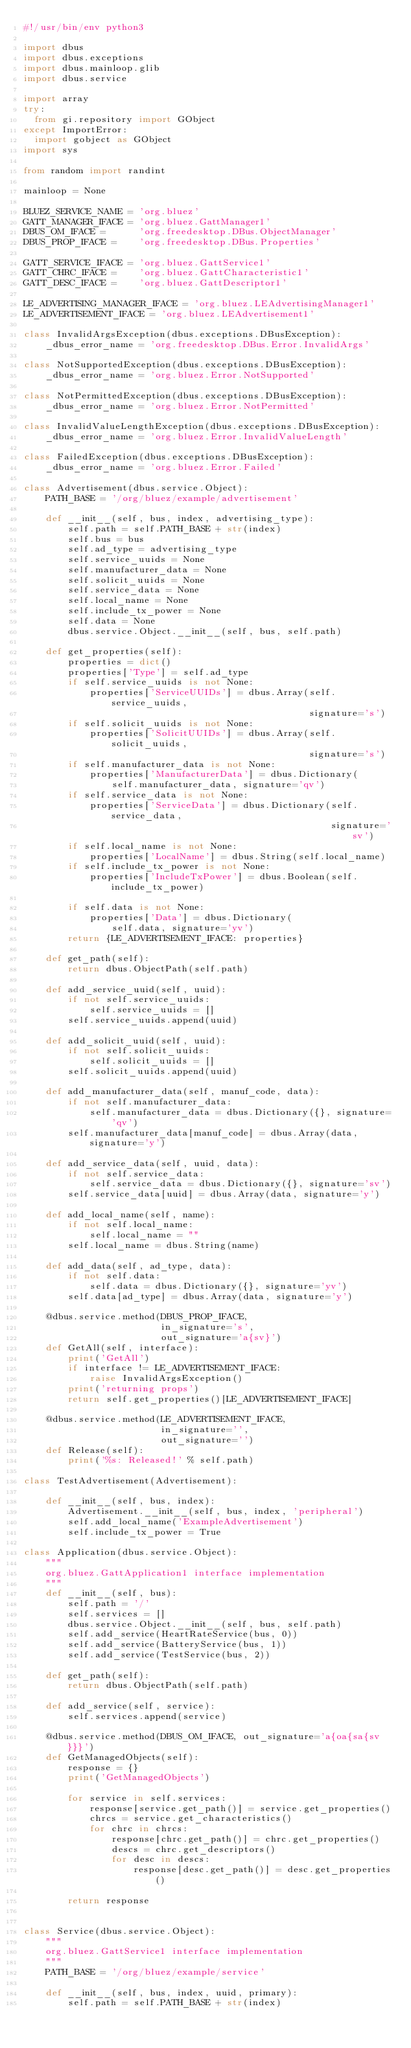Convert code to text. <code><loc_0><loc_0><loc_500><loc_500><_Python_>#!/usr/bin/env python3

import dbus
import dbus.exceptions
import dbus.mainloop.glib
import dbus.service

import array
try:
  from gi.repository import GObject
except ImportError:
  import gobject as GObject
import sys

from random import randint

mainloop = None

BLUEZ_SERVICE_NAME = 'org.bluez'
GATT_MANAGER_IFACE = 'org.bluez.GattManager1'
DBUS_OM_IFACE =      'org.freedesktop.DBus.ObjectManager'
DBUS_PROP_IFACE =    'org.freedesktop.DBus.Properties'

GATT_SERVICE_IFACE = 'org.bluez.GattService1'
GATT_CHRC_IFACE =    'org.bluez.GattCharacteristic1'
GATT_DESC_IFACE =    'org.bluez.GattDescriptor1'

LE_ADVERTISING_MANAGER_IFACE = 'org.bluez.LEAdvertisingManager1'
LE_ADVERTISEMENT_IFACE = 'org.bluez.LEAdvertisement1'

class InvalidArgsException(dbus.exceptions.DBusException):
    _dbus_error_name = 'org.freedesktop.DBus.Error.InvalidArgs'

class NotSupportedException(dbus.exceptions.DBusException):
    _dbus_error_name = 'org.bluez.Error.NotSupported'

class NotPermittedException(dbus.exceptions.DBusException):
    _dbus_error_name = 'org.bluez.Error.NotPermitted'

class InvalidValueLengthException(dbus.exceptions.DBusException):
    _dbus_error_name = 'org.bluez.Error.InvalidValueLength'

class FailedException(dbus.exceptions.DBusException):
    _dbus_error_name = 'org.bluez.Error.Failed'

class Advertisement(dbus.service.Object):
    PATH_BASE = '/org/bluez/example/advertisement'

    def __init__(self, bus, index, advertising_type):
        self.path = self.PATH_BASE + str(index)
        self.bus = bus
        self.ad_type = advertising_type
        self.service_uuids = None
        self.manufacturer_data = None
        self.solicit_uuids = None
        self.service_data = None
        self.local_name = None
        self.include_tx_power = None
        self.data = None
        dbus.service.Object.__init__(self, bus, self.path)

    def get_properties(self):
        properties = dict()
        properties['Type'] = self.ad_type
        if self.service_uuids is not None:
            properties['ServiceUUIDs'] = dbus.Array(self.service_uuids,
                                                    signature='s')
        if self.solicit_uuids is not None:
            properties['SolicitUUIDs'] = dbus.Array(self.solicit_uuids,
                                                    signature='s')
        if self.manufacturer_data is not None:
            properties['ManufacturerData'] = dbus.Dictionary(
                self.manufacturer_data, signature='qv')
        if self.service_data is not None:
            properties['ServiceData'] = dbus.Dictionary(self.service_data,
                                                        signature='sv')
        if self.local_name is not None:
            properties['LocalName'] = dbus.String(self.local_name)
        if self.include_tx_power is not None:
            properties['IncludeTxPower'] = dbus.Boolean(self.include_tx_power)

        if self.data is not None:
            properties['Data'] = dbus.Dictionary(
                self.data, signature='yv')
        return {LE_ADVERTISEMENT_IFACE: properties}

    def get_path(self):
        return dbus.ObjectPath(self.path)

    def add_service_uuid(self, uuid):
        if not self.service_uuids:
            self.service_uuids = []
        self.service_uuids.append(uuid)

    def add_solicit_uuid(self, uuid):
        if not self.solicit_uuids:
            self.solicit_uuids = []
        self.solicit_uuids.append(uuid)

    def add_manufacturer_data(self, manuf_code, data):
        if not self.manufacturer_data:
            self.manufacturer_data = dbus.Dictionary({}, signature='qv')
        self.manufacturer_data[manuf_code] = dbus.Array(data, signature='y')

    def add_service_data(self, uuid, data):
        if not self.service_data:
            self.service_data = dbus.Dictionary({}, signature='sv')
        self.service_data[uuid] = dbus.Array(data, signature='y')

    def add_local_name(self, name):
        if not self.local_name:
            self.local_name = ""
        self.local_name = dbus.String(name)

    def add_data(self, ad_type, data):
        if not self.data:
            self.data = dbus.Dictionary({}, signature='yv')
        self.data[ad_type] = dbus.Array(data, signature='y')

    @dbus.service.method(DBUS_PROP_IFACE,
                         in_signature='s',
                         out_signature='a{sv}')
    def GetAll(self, interface):
        print('GetAll')
        if interface != LE_ADVERTISEMENT_IFACE:
            raise InvalidArgsException()
        print('returning props')
        return self.get_properties()[LE_ADVERTISEMENT_IFACE]

    @dbus.service.method(LE_ADVERTISEMENT_IFACE,
                         in_signature='',
                         out_signature='')
    def Release(self):
        print('%s: Released!' % self.path)

class TestAdvertisement(Advertisement):

    def __init__(self, bus, index):
        Advertisement.__init__(self, bus, index, 'peripheral')
        self.add_local_name('ExampleAdvertisement')
        self.include_tx_power = True

class Application(dbus.service.Object):
    """
    org.bluez.GattApplication1 interface implementation
    """
    def __init__(self, bus):
        self.path = '/'
        self.services = []
        dbus.service.Object.__init__(self, bus, self.path)
        self.add_service(HeartRateService(bus, 0))
        self.add_service(BatteryService(bus, 1))
        self.add_service(TestService(bus, 2))

    def get_path(self):
        return dbus.ObjectPath(self.path)

    def add_service(self, service):
        self.services.append(service)

    @dbus.service.method(DBUS_OM_IFACE, out_signature='a{oa{sa{sv}}}')
    def GetManagedObjects(self):
        response = {}
        print('GetManagedObjects')

        for service in self.services:
            response[service.get_path()] = service.get_properties()
            chrcs = service.get_characteristics()
            for chrc in chrcs:
                response[chrc.get_path()] = chrc.get_properties()
                descs = chrc.get_descriptors()
                for desc in descs:
                    response[desc.get_path()] = desc.get_properties()

        return response


class Service(dbus.service.Object):
    """
    org.bluez.GattService1 interface implementation
    """
    PATH_BASE = '/org/bluez/example/service'

    def __init__(self, bus, index, uuid, primary):
        self.path = self.PATH_BASE + str(index)</code> 